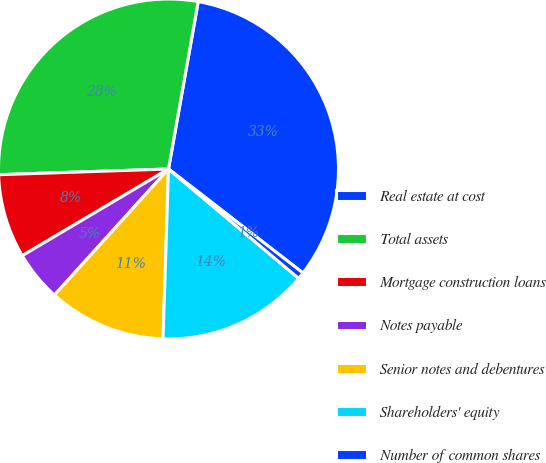Convert chart. <chart><loc_0><loc_0><loc_500><loc_500><pie_chart><fcel>Real estate at cost<fcel>Total assets<fcel>Mortgage construction loans<fcel>Notes payable<fcel>Senior notes and debentures<fcel>Shareholders' equity<fcel>Number of common shares<nl><fcel>32.68%<fcel>28.33%<fcel>7.98%<fcel>4.78%<fcel>11.19%<fcel>14.39%<fcel>0.65%<nl></chart> 